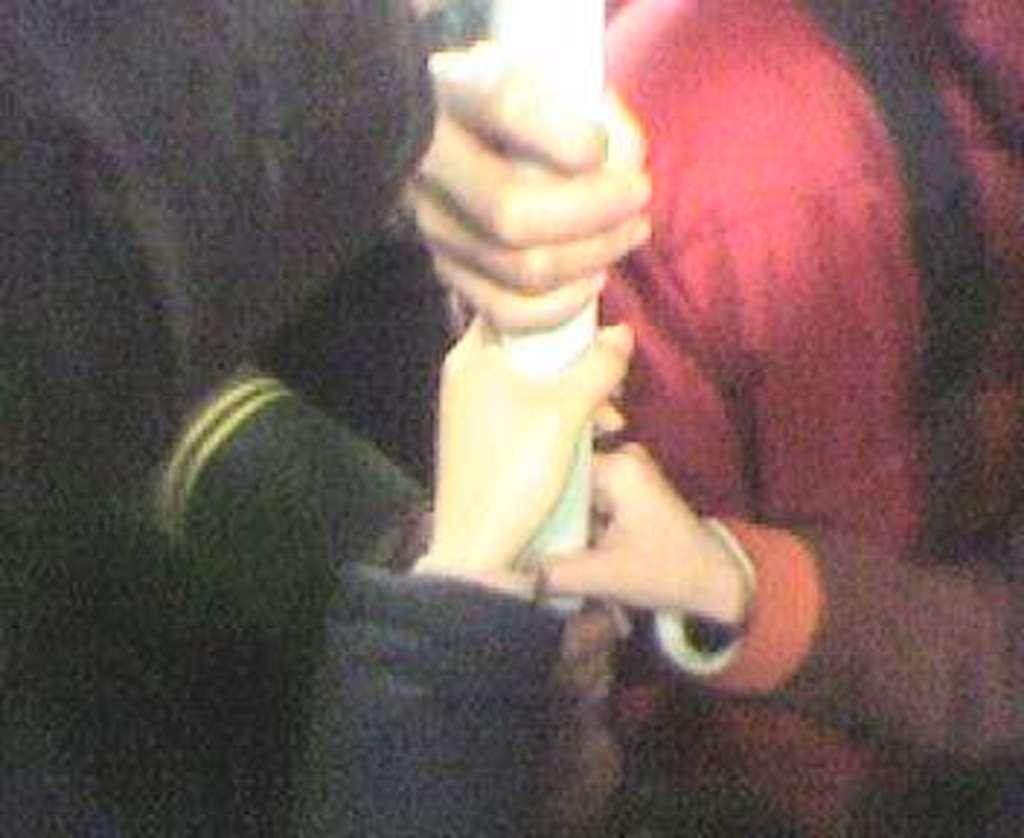How many people are in the image? There are two persons in the image. What are the two persons doing in the image? The hands of the two persons are holding a pole. What is the color of the pole they are holding? The pole is white in color. What type of fuel is being used by the persons in the image? There is no indication of any fuel being used in the image; the two persons are simply holding a white pole. 